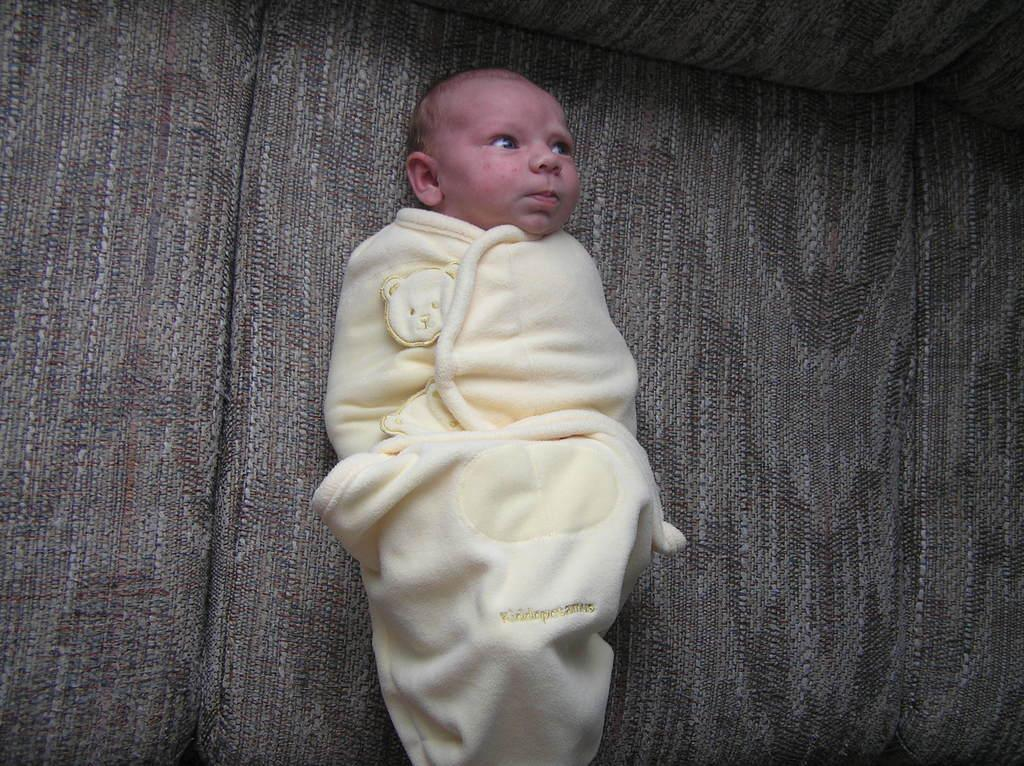What is the main subject of the image? The main subject of the image is a small kid. How is the kid dressed or covered in the image? The kid is wrapped in a towel. Where is the kid located in the image? The kid is sleeping on a sofa. What type of flowers can be seen growing from the bulb in the image? There is no bulb or flowers present in the image; it features a small kid wrapped in a towel and sleeping on a sofa. 